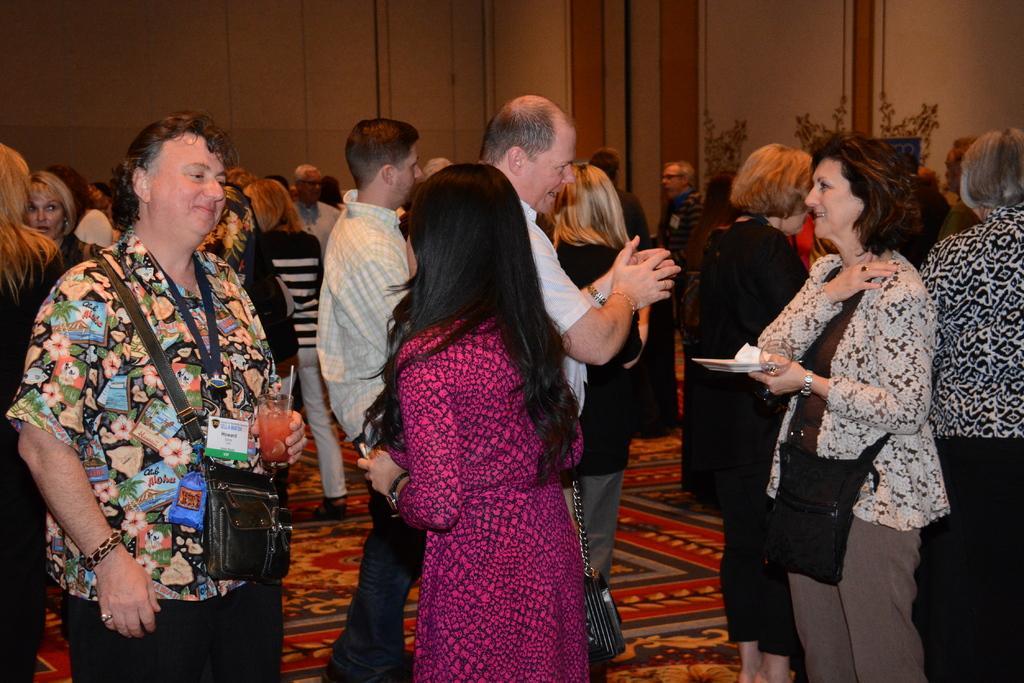Please provide a concise description of this image. In this picture, we see many people are standing. The man on the left side is wearing the bag. He is holding a glass containing the liquid in his hand and he is smiling. The woman on the right side is standing. She is holding a plate and a glass in her hands. She is smiling. In front of her, we see the man in the white shirt is standing and he is talking. In the background, we see a white wall. At the bottom, we see the carpet. 